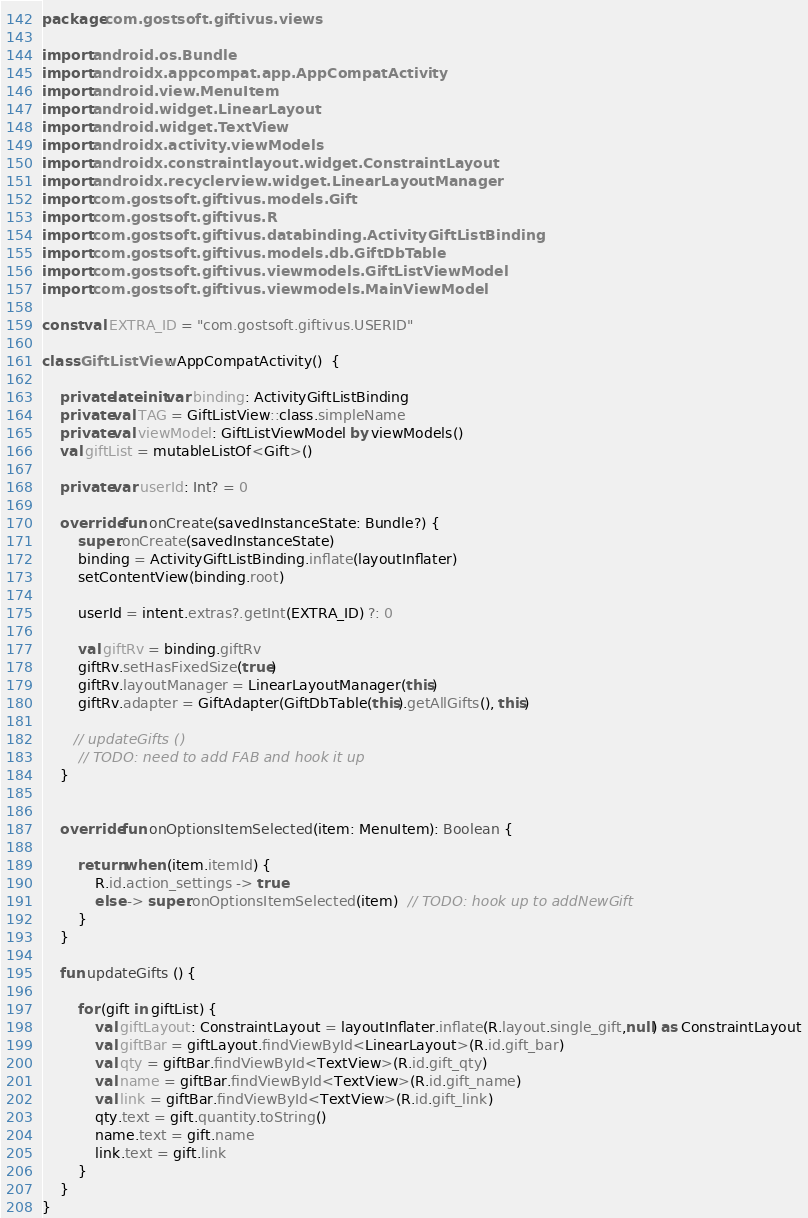Convert code to text. <code><loc_0><loc_0><loc_500><loc_500><_Kotlin_>package com.gostsoft.giftivus.views

import android.os.Bundle
import androidx.appcompat.app.AppCompatActivity
import android.view.MenuItem
import android.widget.LinearLayout
import android.widget.TextView
import androidx.activity.viewModels
import androidx.constraintlayout.widget.ConstraintLayout
import androidx.recyclerview.widget.LinearLayoutManager
import com.gostsoft.giftivus.models.Gift
import com.gostsoft.giftivus.R
import com.gostsoft.giftivus.databinding.ActivityGiftListBinding
import com.gostsoft.giftivus.models.db.GiftDbTable
import com.gostsoft.giftivus.viewmodels.GiftListViewModel
import com.gostsoft.giftivus.viewmodels.MainViewModel

const val EXTRA_ID = "com.gostsoft.giftivus.USERID"

class GiftListView : AppCompatActivity()  {

    private lateinit var binding: ActivityGiftListBinding
    private val TAG = GiftListView::class.simpleName
    private val viewModel: GiftListViewModel by viewModels()
    val giftList = mutableListOf<Gift>()

    private var userId: Int? = 0

    override fun onCreate(savedInstanceState: Bundle?) {
        super.onCreate(savedInstanceState)
        binding = ActivityGiftListBinding.inflate(layoutInflater)
        setContentView(binding.root)

        userId = intent.extras?.getInt(EXTRA_ID) ?: 0

        val giftRv = binding.giftRv
        giftRv.setHasFixedSize(true)
        giftRv.layoutManager = LinearLayoutManager(this)
        giftRv.adapter = GiftAdapter(GiftDbTable(this).getAllGifts(), this)

       // updateGifts ()
        // TODO: need to add FAB and hook it up
    }


    override fun onOptionsItemSelected(item: MenuItem): Boolean {

        return when (item.itemId) {
            R.id.action_settings -> true
            else -> super.onOptionsItemSelected(item)  // TODO: hook up to addNewGift
        }
    }

    fun updateGifts () {

        for (gift in giftList) {
            val giftLayout: ConstraintLayout = layoutInflater.inflate(R.layout.single_gift,null) as ConstraintLayout
            val giftBar = giftLayout.findViewById<LinearLayout>(R.id.gift_bar)
            val qty = giftBar.findViewById<TextView>(R.id.gift_qty)
            val name = giftBar.findViewById<TextView>(R.id.gift_name)
            val link = giftBar.findViewById<TextView>(R.id.gift_link)
            qty.text = gift.quantity.toString()
            name.text = gift.name
            link.text = gift.link
        }
    }
}</code> 